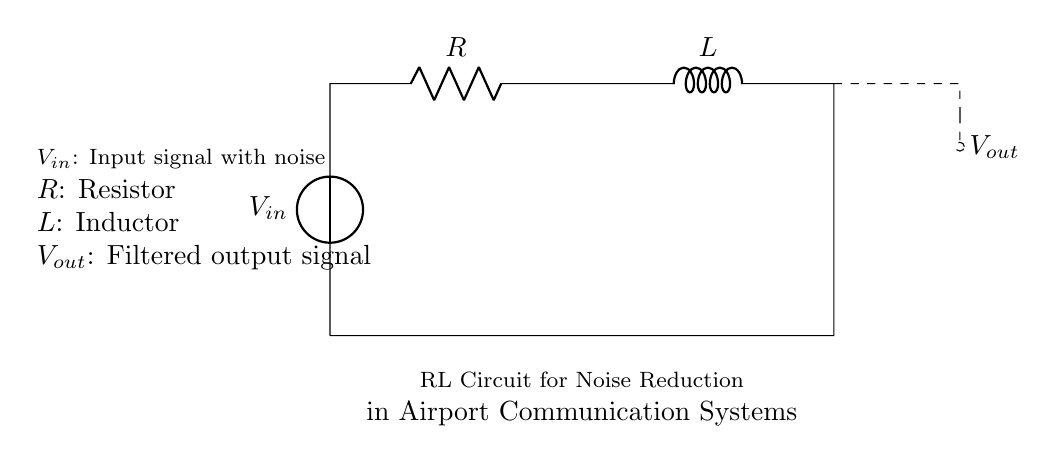What type of circuit is displayed? The circuit shown is an RL circuit, which consists of a resistor and an inductor connected in series.
Answer: RL circuit What is the purpose of the resistor in this circuit? The resistor is used to limit the current flowing through the circuit and to help in the dissipation of noise.
Answer: Limit current What does the inductor do in this circuit? The inductor stores energy in a magnetic field and helps to smooth out fluctuations in the output signal, thereby reducing noise.
Answer: Reduce noise What is the output voltage referred to as? The output voltage is labeled as Vout in the circuit diagram, which is the filtered signal after passing through the RL components.
Answer: Vout How do the resistor and inductor work together in this circuit? The resistor and inductor in series create a low-pass filter that attenuates high-frequency noise while allowing lower-frequency signal components to pass through.
Answer: Low-pass filter What happens to high-frequency noise in this RL circuit? High-frequency noise is attenuated due to the reactance of the inductor, meaning it is significantly reduced at the output compared to lower-frequency signals.
Answer: Attenuated 